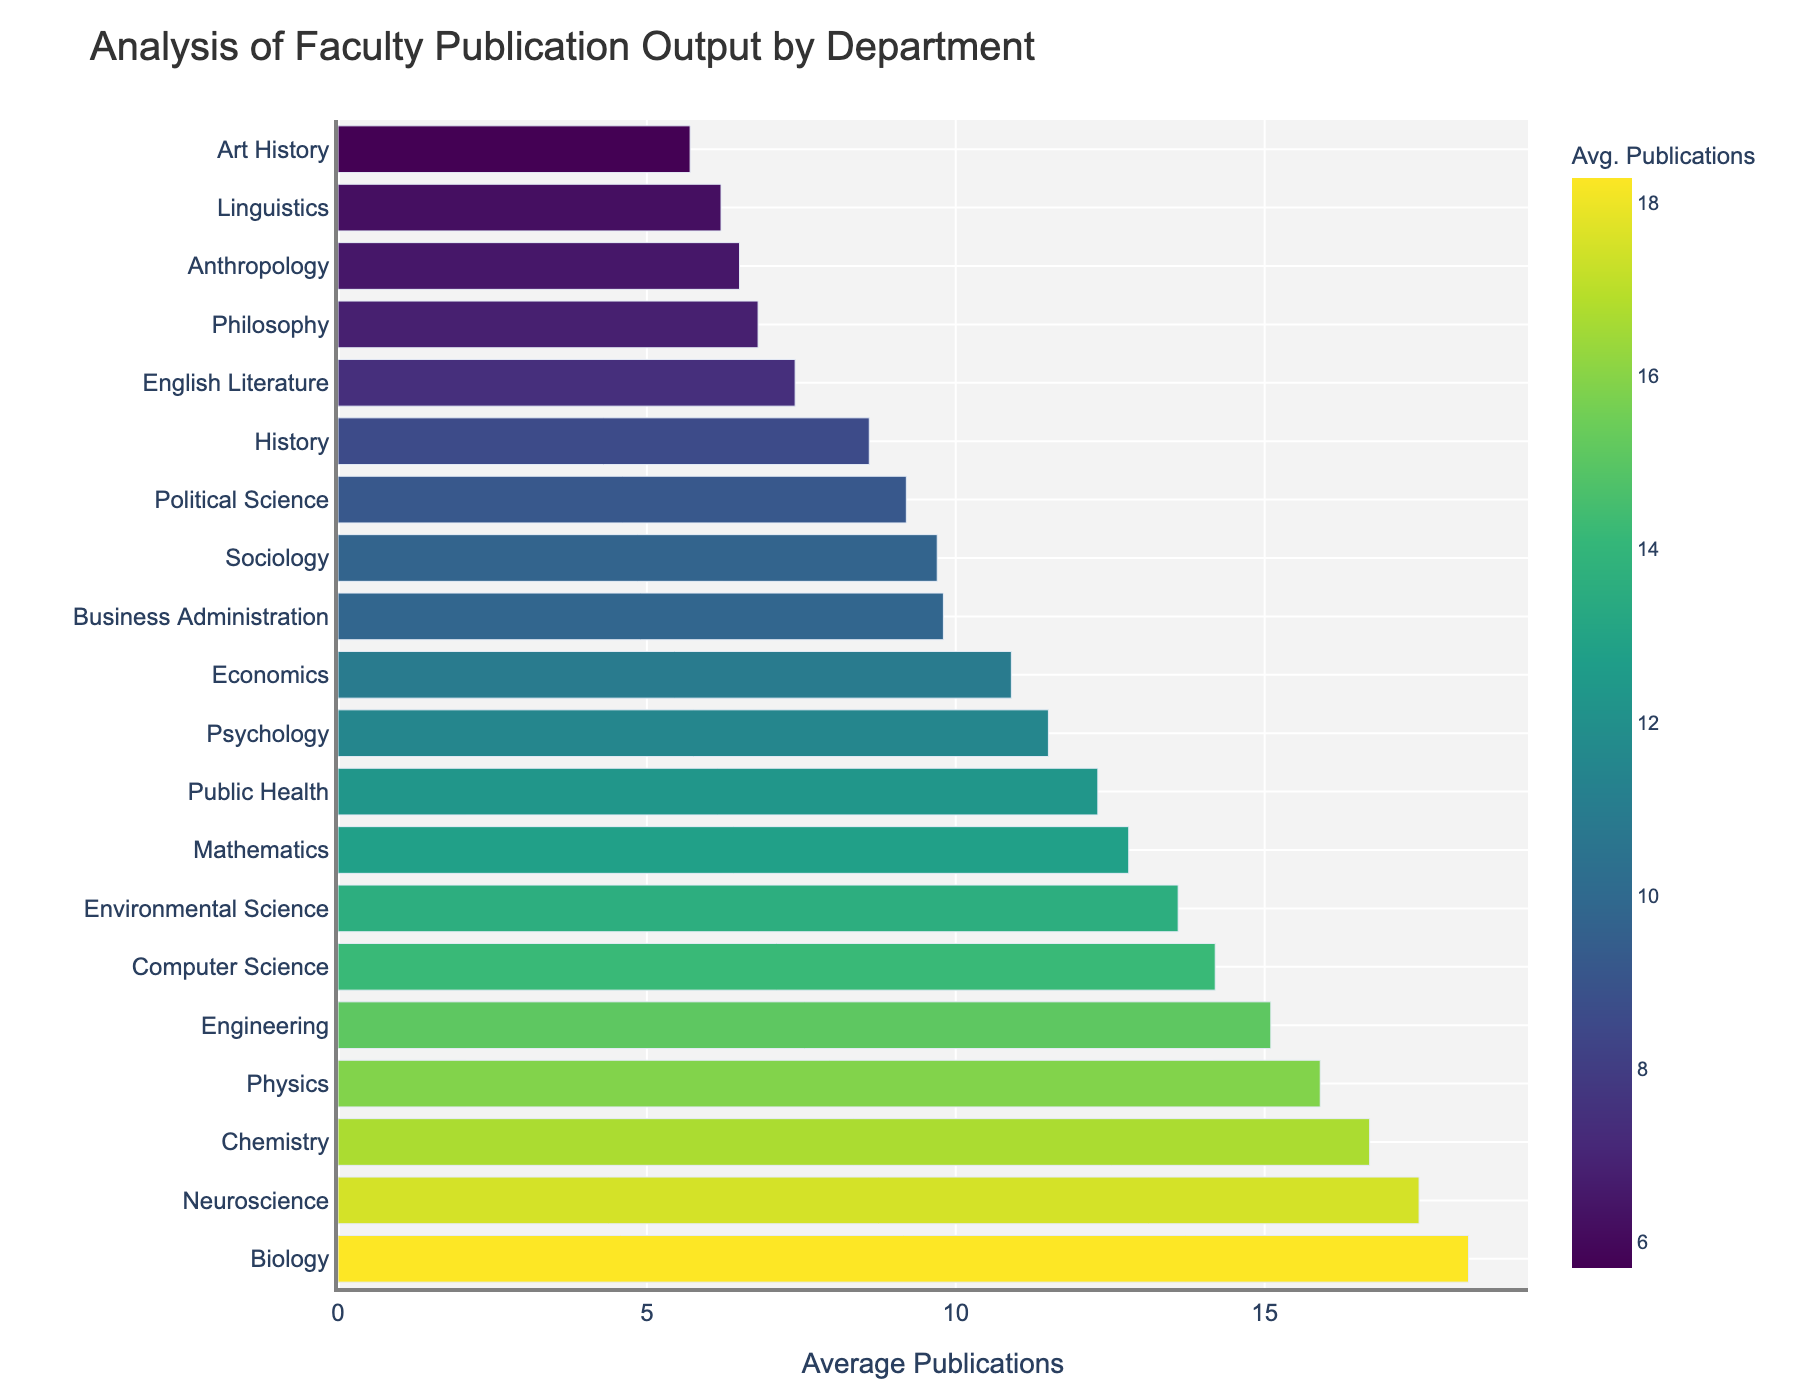Which department has the highest average publications per faculty member? Look at the bar with the longest length on the plot. Identify the corresponding department label next to it.
Answer: Biology Which department has the lowest average publications per faculty member? Look at the bar with the shortest length on the plot. Identify the corresponding department label next to it.
Answer: Art History How many more average publications per faculty member does Biology have compared to English Literature? Find the average publications for Biology (18.3) and English Literature (7.4), then subtract the latter from the former: 18.3 - 7.4.
Answer: 10.9 Rank the top three departments by average publications per faculty member. Identify and list the departments corresponding to the top three longest bars on the chart in descending order.
Answer: Biology, Neuroscience, Chemistry Does the Psychology department have more average publications per faculty member than Sociology? Find the average publications for both departments (Psychology: 11.5, Sociology: 9.7) and compare the two values.
Answer: Yes Compare the average publications per faculty member in Computer Science and Mathematics. Which department has more? Find the average publications for both departments (Computer Science: 14.2, Mathematics: 12.8) and compare the two values.
Answer: Computer Science What is the combined average publications per faculty member for the departments of History and Philosophy? Add the average publications of History (8.6) and Philosophy (6.8): 8.6 + 6.8.
Answer: 15.4 Which department appears closest to the median of average publications per faculty member among all listed departments? Organize all departments' average publications in ascending order and find the median value. Identify the corresponding department. This is Environment Science at 13.6 or Engineering at 15.1 due to the median lies between them.
Answer: Environmental Science or Engineering How does the average publication output of the Political Science department compare to the Mathematics department? Find the average publications for both departments (Political Science: 9.2, Mathematics: 12.8) and compare the two values.
Answer: Mathematics has more What is the difference in average publications per faculty member between departments with the fourth and fifth highest publication rates? Identify the fourth and fifth departments (Computer Science: 14.2, Environmental Science: 13.6), then subtract the latter from the former: 14.2 - 13.6.
Answer: 0.6 